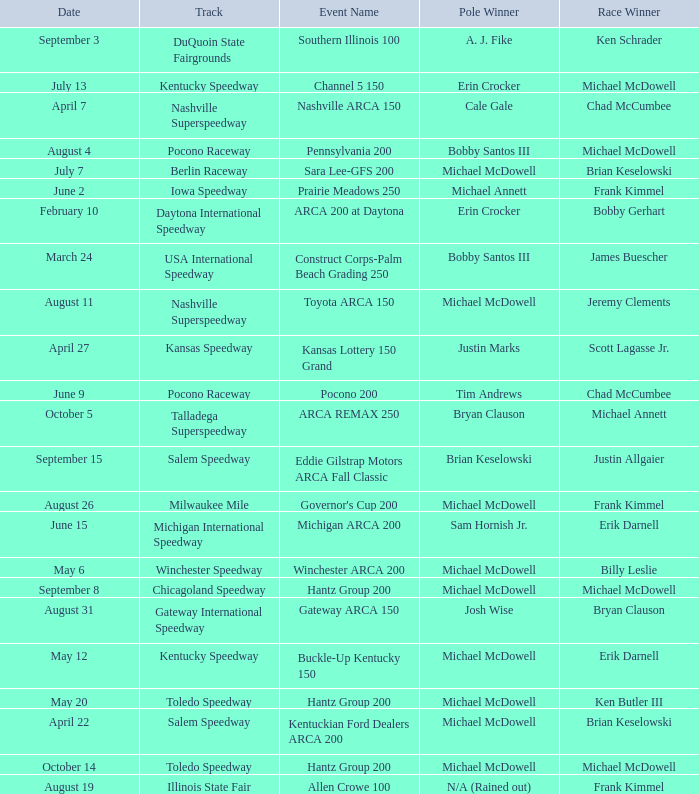Tell me the pole winner of may 12 Michael McDowell. 